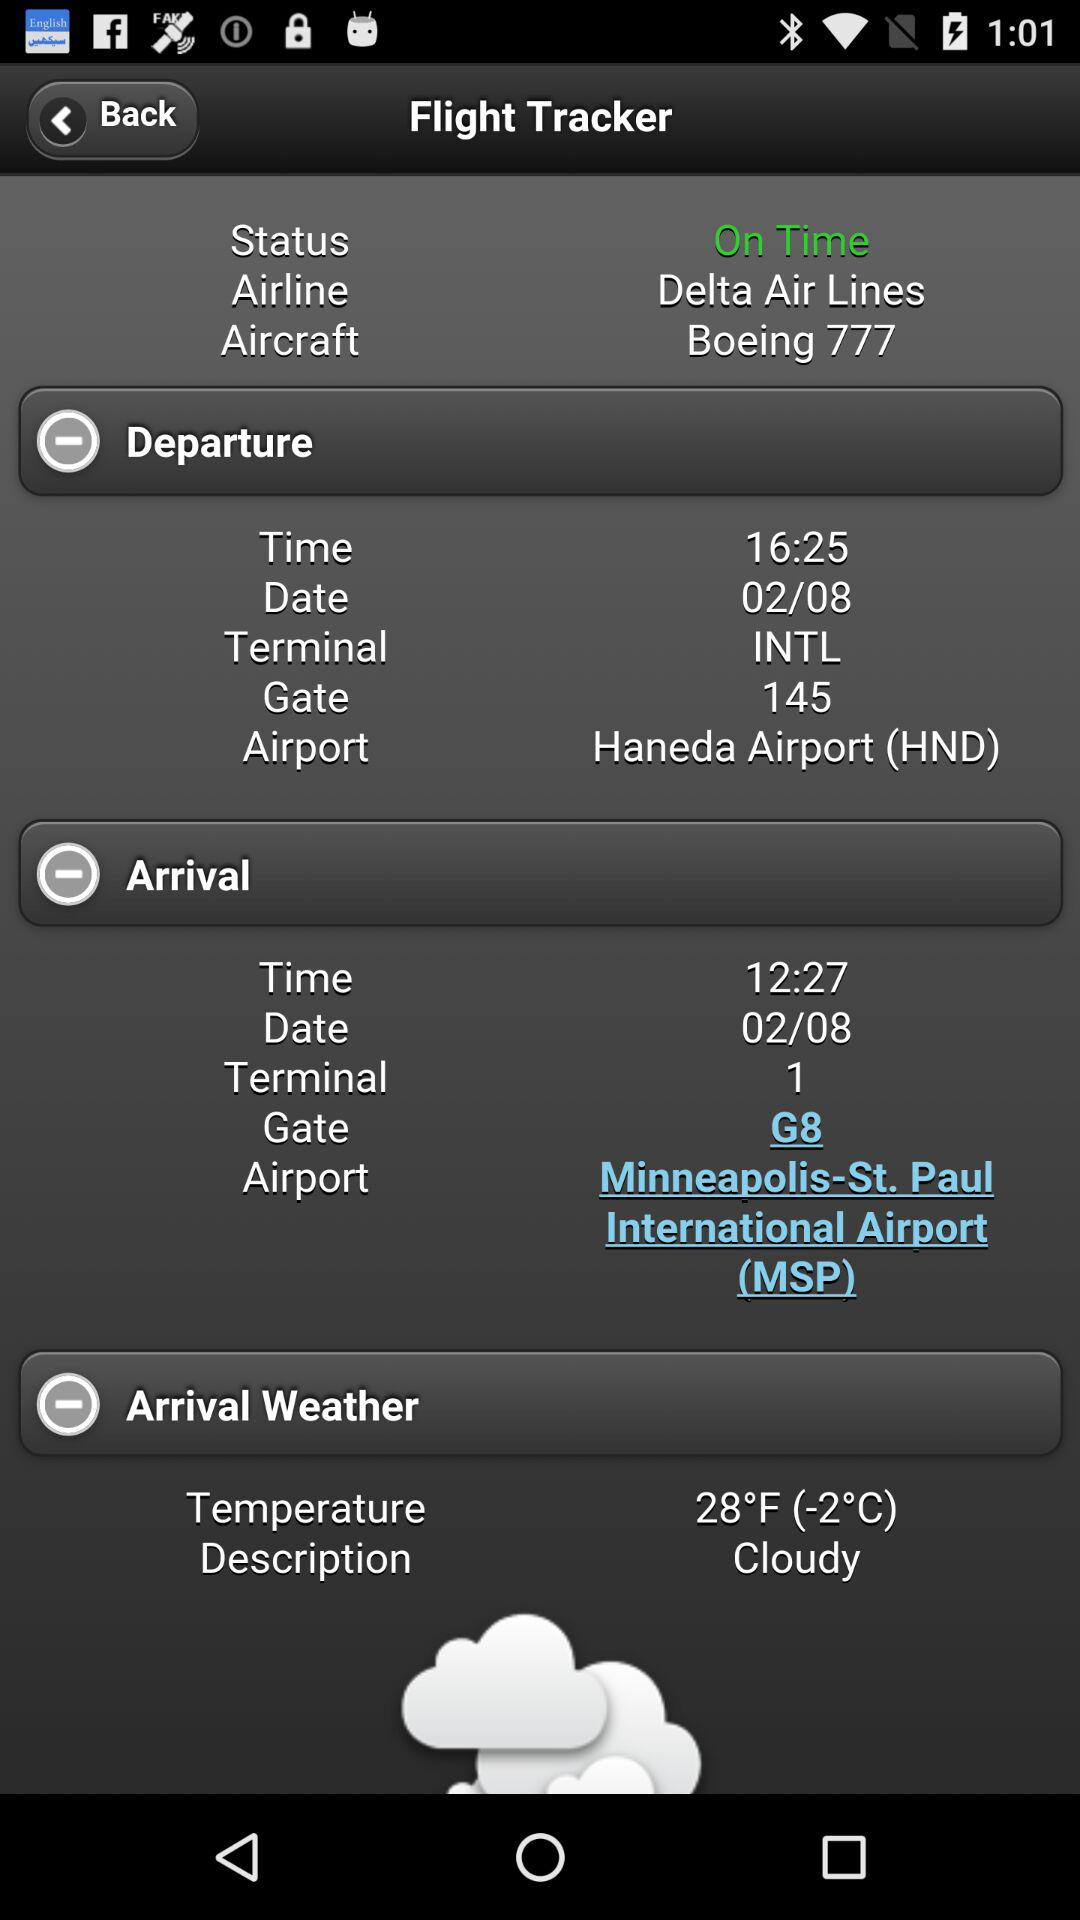What is the departure terminal? The departure terminal is "INTL". 